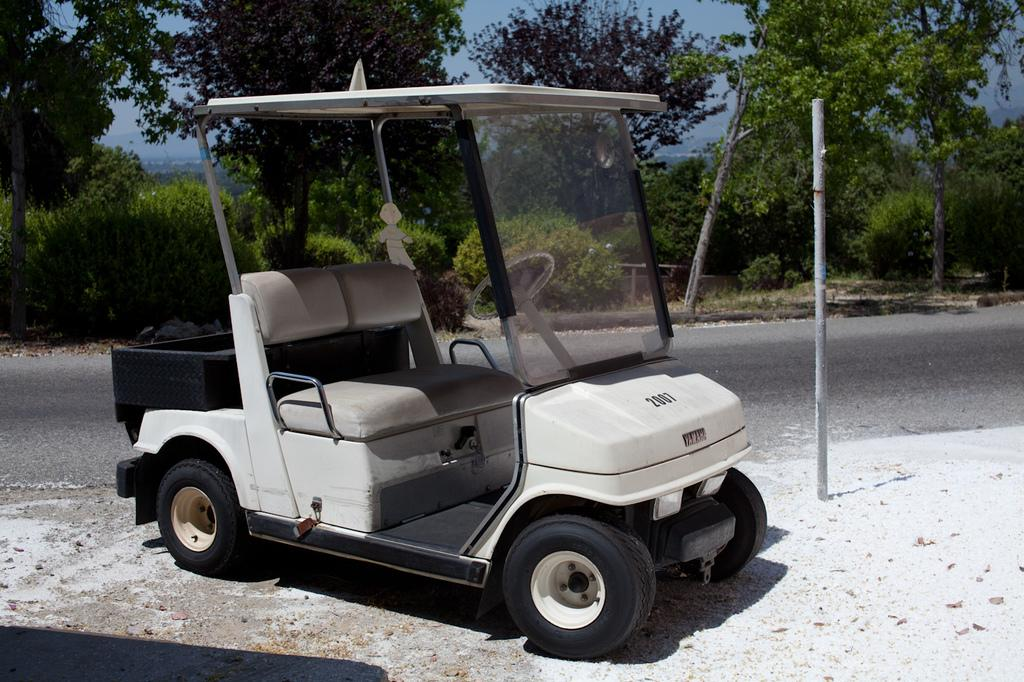What is the main subject of the image? There is a vehicle on the road in the image. What can be seen in the background of the image? There are trees and the sky visible in the background of the image. What type of jeans is the vehicle wearing in the image? Vehicles do not wear jeans, as they are inanimate objects. 